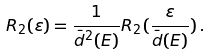<formula> <loc_0><loc_0><loc_500><loc_500>R _ { 2 } ( \varepsilon ) = \frac { 1 } { \bar { d } ^ { 2 } ( E ) } R _ { 2 } ( \frac { \varepsilon } { \bar { d } ( E ) } ) \, .</formula> 